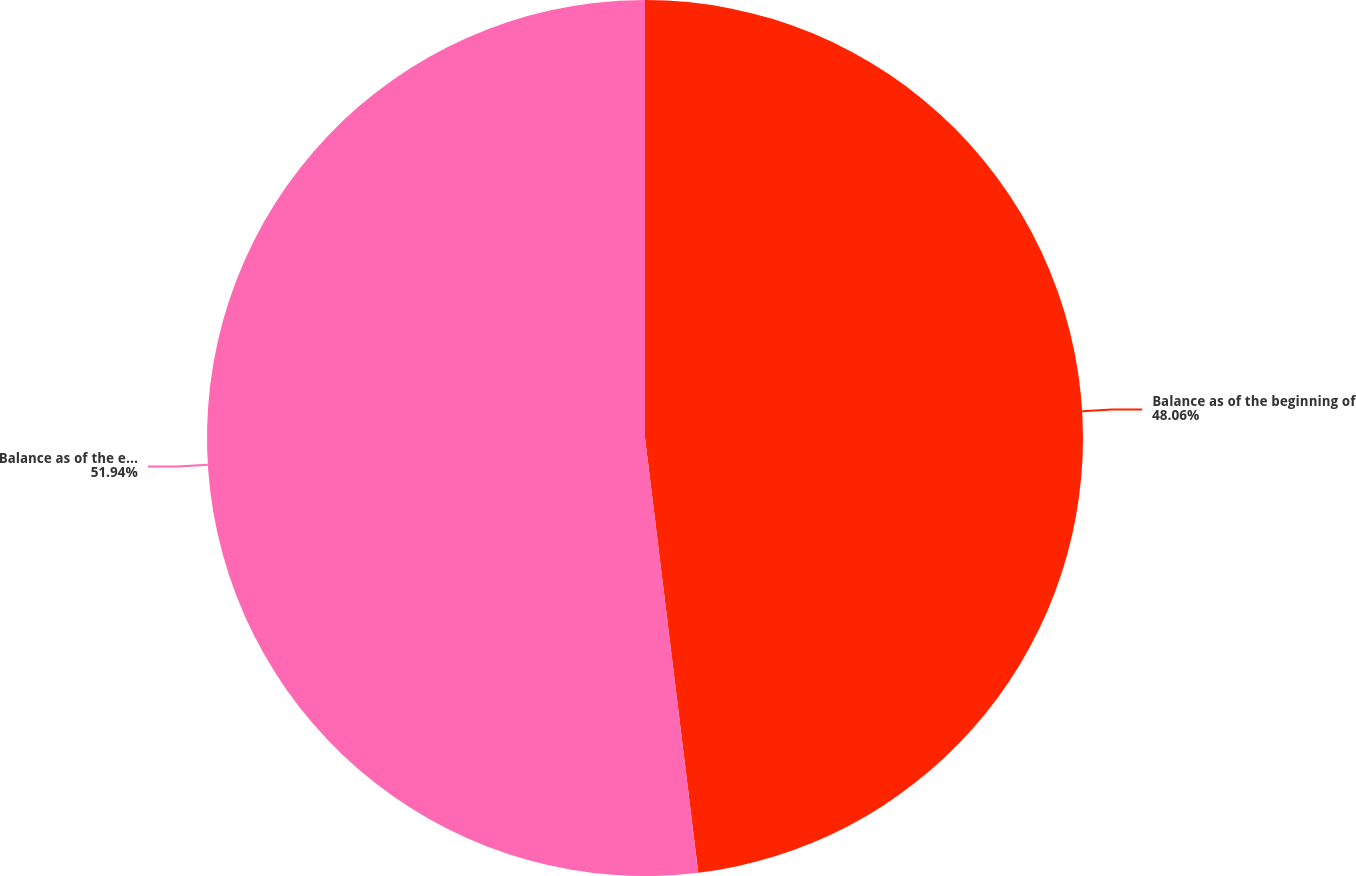Convert chart. <chart><loc_0><loc_0><loc_500><loc_500><pie_chart><fcel>Balance as of the beginning of<fcel>Balance as of the end of the<nl><fcel>48.06%<fcel>51.94%<nl></chart> 